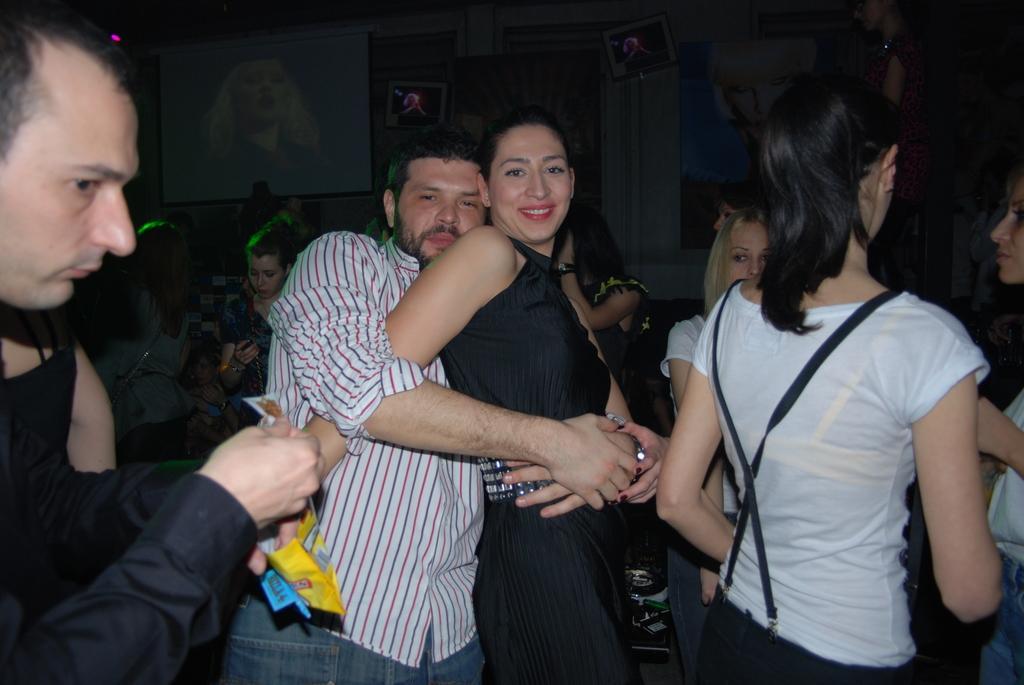Could you give a brief overview of what you see in this image? In this image I see number of people in which this man is holding this woman and I see that this woman is smiling and I see that this man is holding in his hand. In the background I see a screen over here and I see the light over here and it is a bit dark in the background. 